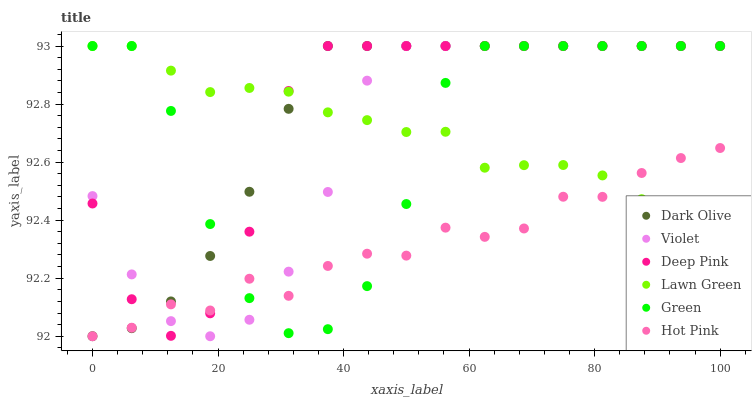Does Hot Pink have the minimum area under the curve?
Answer yes or no. Yes. Does Dark Olive have the maximum area under the curve?
Answer yes or no. Yes. Does Dark Olive have the minimum area under the curve?
Answer yes or no. No. Does Hot Pink have the maximum area under the curve?
Answer yes or no. No. Is Dark Olive the smoothest?
Answer yes or no. Yes. Is Green the roughest?
Answer yes or no. Yes. Is Hot Pink the smoothest?
Answer yes or no. No. Is Hot Pink the roughest?
Answer yes or no. No. Does Hot Pink have the lowest value?
Answer yes or no. Yes. Does Dark Olive have the lowest value?
Answer yes or no. No. Does Violet have the highest value?
Answer yes or no. Yes. Does Hot Pink have the highest value?
Answer yes or no. No. Does Deep Pink intersect Violet?
Answer yes or no. Yes. Is Deep Pink less than Violet?
Answer yes or no. No. Is Deep Pink greater than Violet?
Answer yes or no. No. 